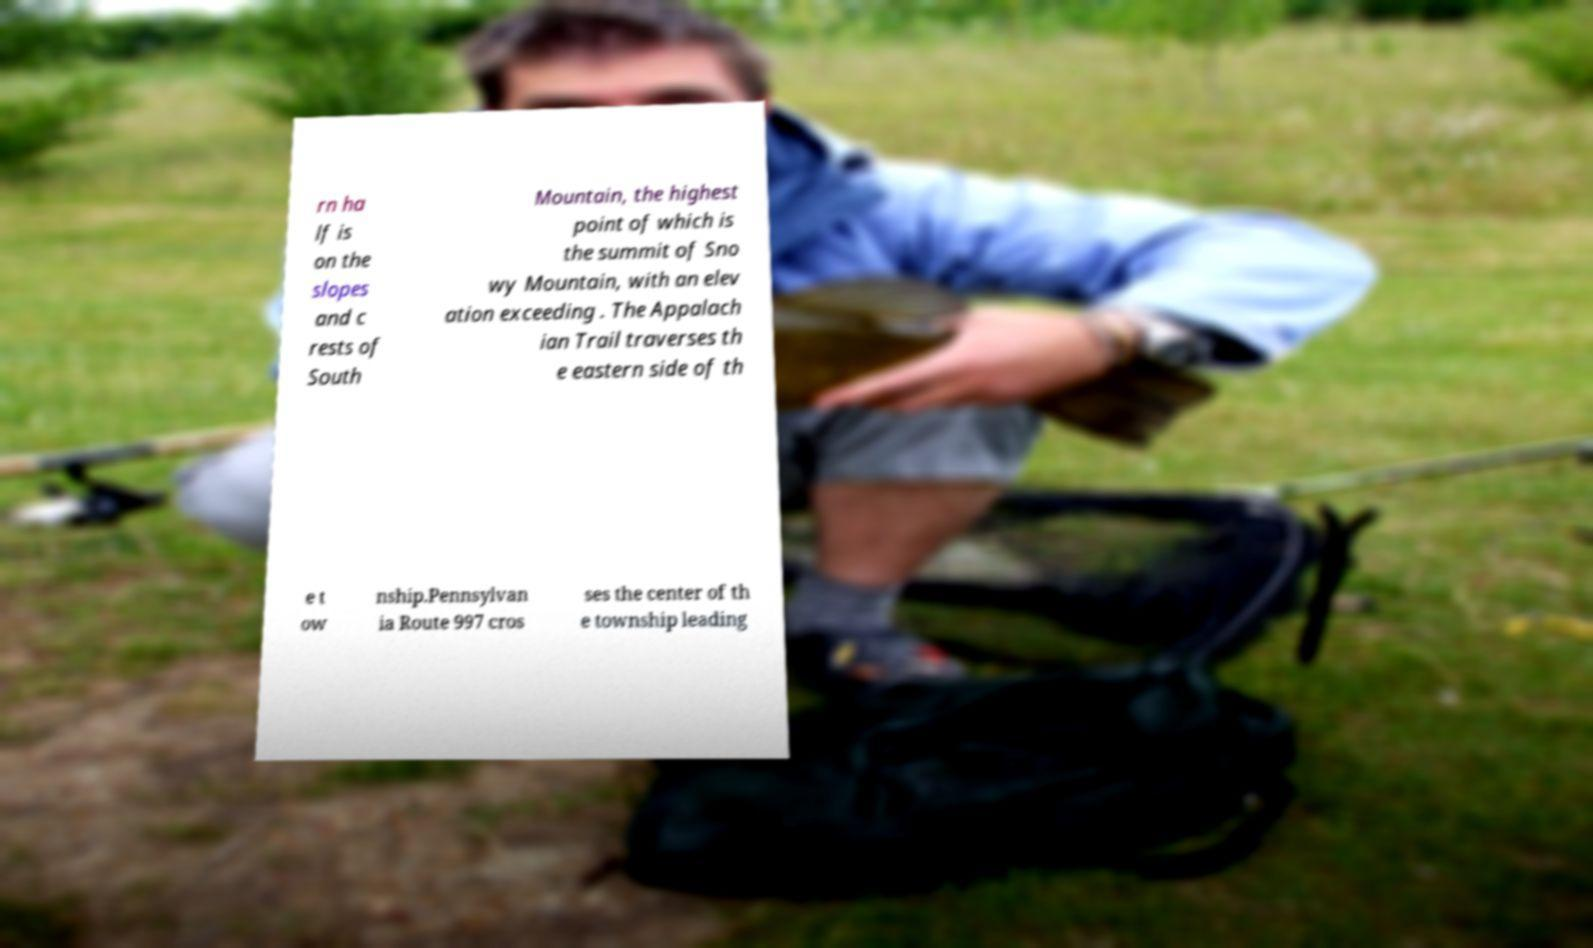For documentation purposes, I need the text within this image transcribed. Could you provide that? rn ha lf is on the slopes and c rests of South Mountain, the highest point of which is the summit of Sno wy Mountain, with an elev ation exceeding . The Appalach ian Trail traverses th e eastern side of th e t ow nship.Pennsylvan ia Route 997 cros ses the center of th e township leading 